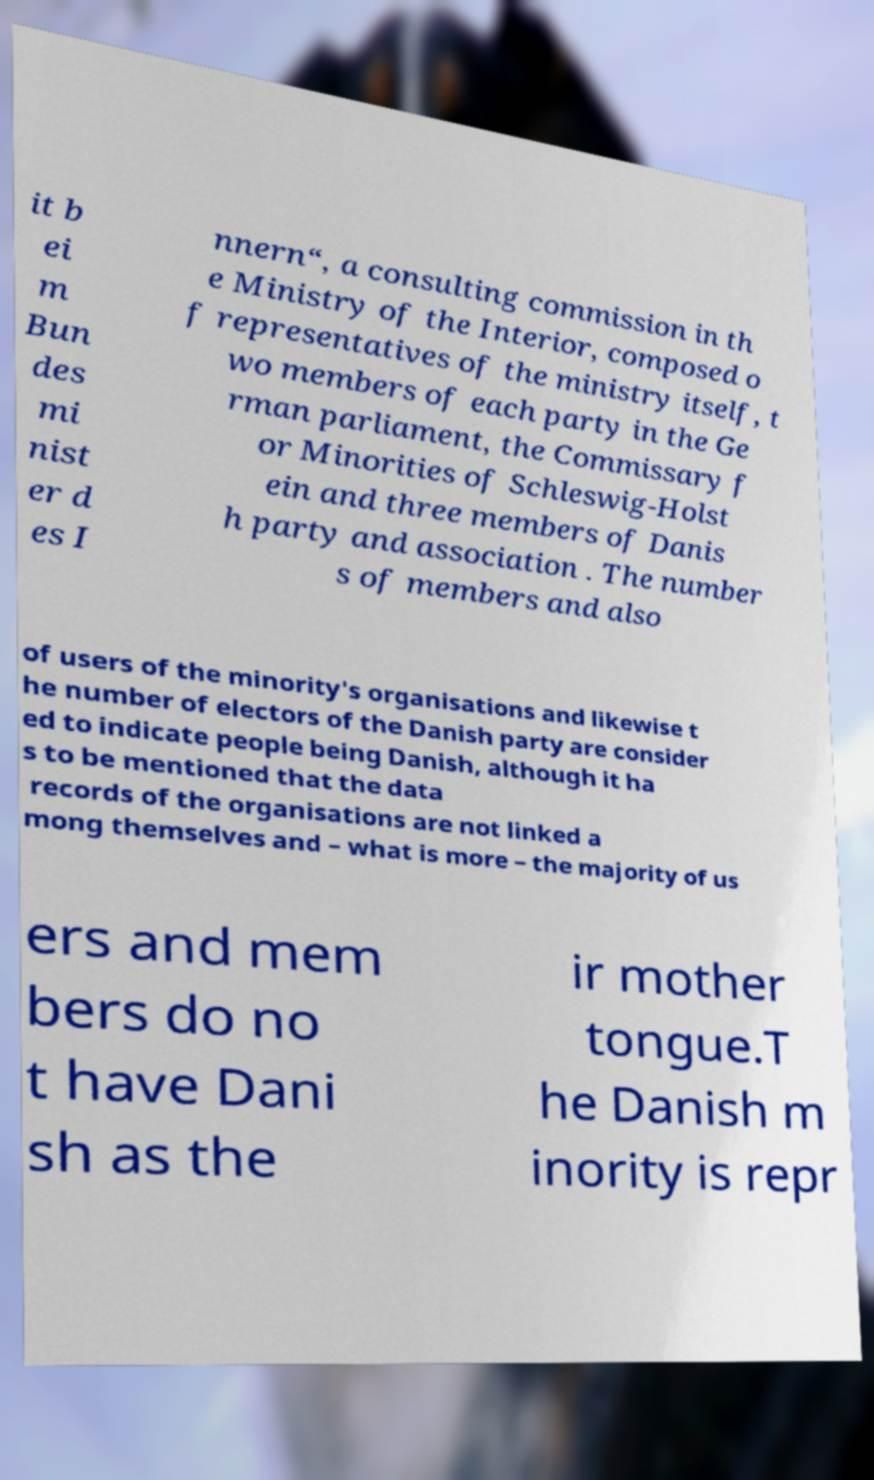Could you extract and type out the text from this image? it b ei m Bun des mi nist er d es I nnern“, a consulting commission in th e Ministry of the Interior, composed o f representatives of the ministry itself, t wo members of each party in the Ge rman parliament, the Commissary f or Minorities of Schleswig-Holst ein and three members of Danis h party and association . The number s of members and also of users of the minority's organisations and likewise t he number of electors of the Danish party are consider ed to indicate people being Danish, although it ha s to be mentioned that the data records of the organisations are not linked a mong themselves and – what is more – the majority of us ers and mem bers do no t have Dani sh as the ir mother tongue.T he Danish m inority is repr 